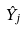<formula> <loc_0><loc_0><loc_500><loc_500>\hat { Y } _ { j }</formula> 